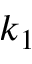Convert formula to latex. <formula><loc_0><loc_0><loc_500><loc_500>k _ { 1 }</formula> 